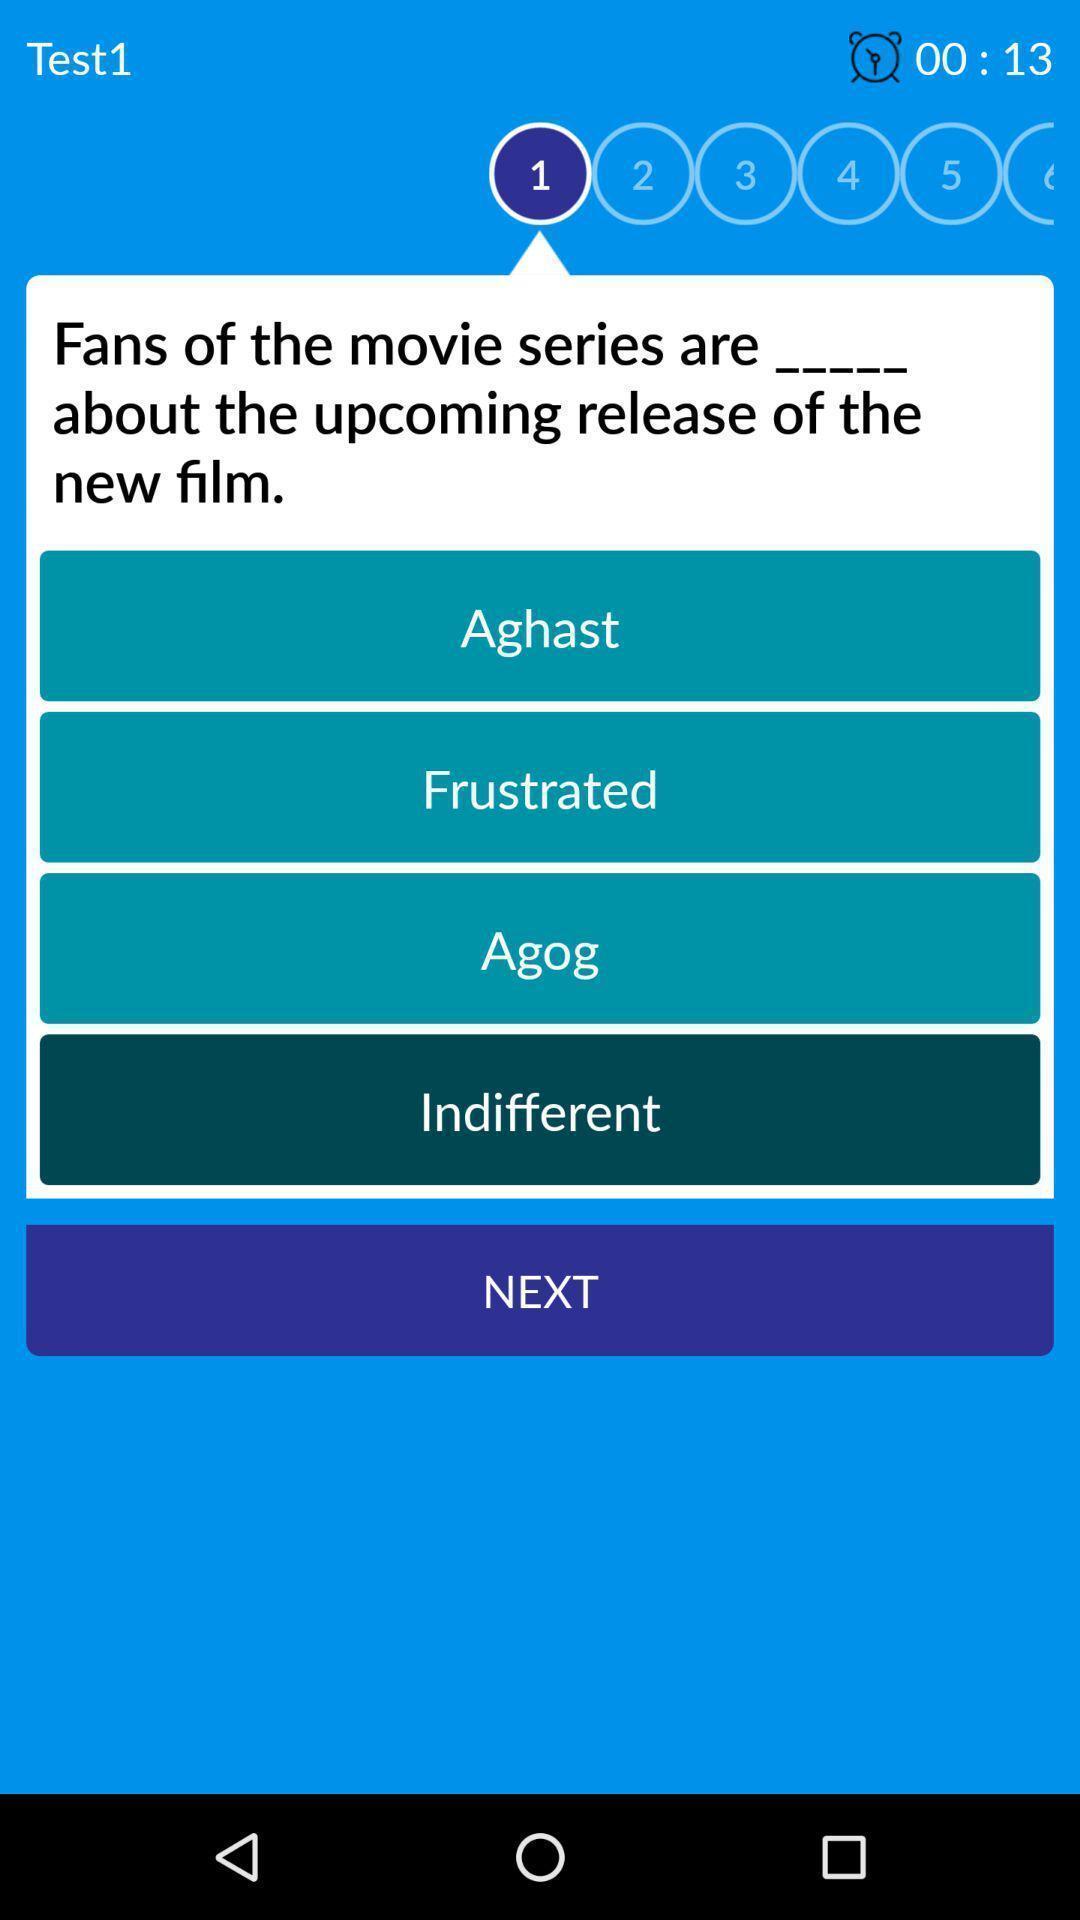What details can you identify in this image? Screen displaying a question on a learning app. 